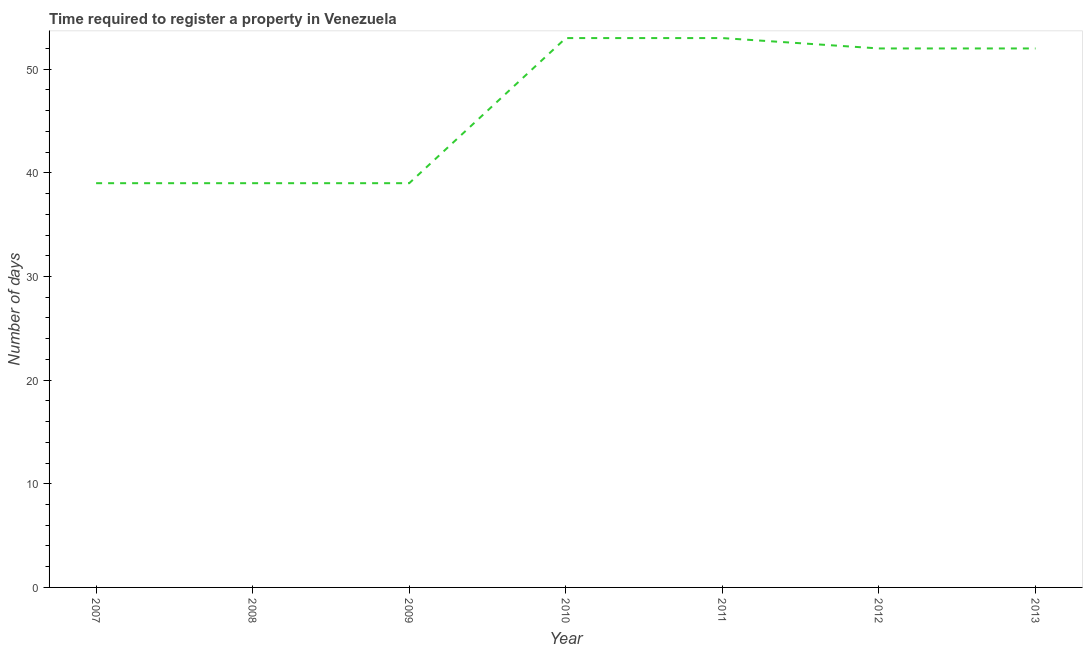What is the number of days required to register property in 2012?
Your response must be concise. 52. Across all years, what is the maximum number of days required to register property?
Your response must be concise. 53. Across all years, what is the minimum number of days required to register property?
Give a very brief answer. 39. In which year was the number of days required to register property minimum?
Your answer should be compact. 2007. What is the sum of the number of days required to register property?
Your answer should be compact. 327. What is the difference between the number of days required to register property in 2009 and 2013?
Offer a terse response. -13. What is the average number of days required to register property per year?
Your response must be concise. 46.71. What is the median number of days required to register property?
Give a very brief answer. 52. In how many years, is the number of days required to register property greater than 44 days?
Provide a short and direct response. 4. Is the number of days required to register property in 2012 less than that in 2013?
Offer a terse response. No. Is the sum of the number of days required to register property in 2007 and 2012 greater than the maximum number of days required to register property across all years?
Offer a terse response. Yes. What is the difference between the highest and the lowest number of days required to register property?
Provide a short and direct response. 14. How many lines are there?
Offer a terse response. 1. What is the difference between two consecutive major ticks on the Y-axis?
Give a very brief answer. 10. Are the values on the major ticks of Y-axis written in scientific E-notation?
Keep it short and to the point. No. Does the graph contain any zero values?
Make the answer very short. No. Does the graph contain grids?
Your answer should be very brief. No. What is the title of the graph?
Your answer should be compact. Time required to register a property in Venezuela. What is the label or title of the Y-axis?
Make the answer very short. Number of days. What is the Number of days in 2007?
Offer a very short reply. 39. What is the Number of days in 2009?
Keep it short and to the point. 39. What is the Number of days in 2010?
Your answer should be very brief. 53. What is the Number of days of 2013?
Keep it short and to the point. 52. What is the difference between the Number of days in 2007 and 2008?
Your answer should be compact. 0. What is the difference between the Number of days in 2007 and 2010?
Offer a very short reply. -14. What is the difference between the Number of days in 2007 and 2013?
Provide a succinct answer. -13. What is the difference between the Number of days in 2008 and 2011?
Provide a short and direct response. -14. What is the difference between the Number of days in 2008 and 2013?
Offer a very short reply. -13. What is the difference between the Number of days in 2009 and 2010?
Give a very brief answer. -14. What is the difference between the Number of days in 2010 and 2011?
Your response must be concise. 0. What is the difference between the Number of days in 2010 and 2012?
Give a very brief answer. 1. What is the difference between the Number of days in 2011 and 2012?
Your answer should be very brief. 1. What is the difference between the Number of days in 2011 and 2013?
Your response must be concise. 1. What is the ratio of the Number of days in 2007 to that in 2009?
Provide a short and direct response. 1. What is the ratio of the Number of days in 2007 to that in 2010?
Your response must be concise. 0.74. What is the ratio of the Number of days in 2007 to that in 2011?
Ensure brevity in your answer.  0.74. What is the ratio of the Number of days in 2007 to that in 2012?
Offer a terse response. 0.75. What is the ratio of the Number of days in 2007 to that in 2013?
Your answer should be compact. 0.75. What is the ratio of the Number of days in 2008 to that in 2010?
Ensure brevity in your answer.  0.74. What is the ratio of the Number of days in 2008 to that in 2011?
Ensure brevity in your answer.  0.74. What is the ratio of the Number of days in 2009 to that in 2010?
Provide a succinct answer. 0.74. What is the ratio of the Number of days in 2009 to that in 2011?
Make the answer very short. 0.74. What is the ratio of the Number of days in 2009 to that in 2013?
Offer a terse response. 0.75. What is the ratio of the Number of days in 2010 to that in 2012?
Provide a succinct answer. 1.02. What is the ratio of the Number of days in 2011 to that in 2013?
Offer a terse response. 1.02. 